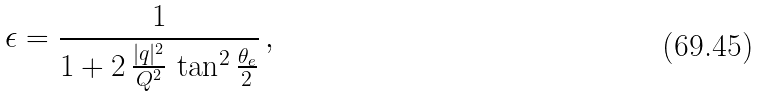<formula> <loc_0><loc_0><loc_500><loc_500>\epsilon = \frac { 1 } { 1 + 2 \, \frac { | q | ^ { 2 } } { Q ^ { 2 } } \, \tan ^ { 2 } \frac { \theta _ { e } } { 2 } } \, ,</formula> 